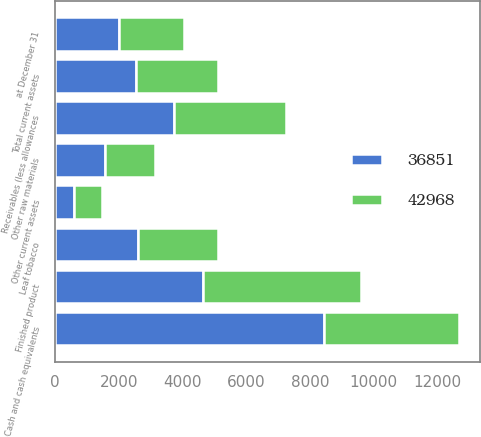Convert chart to OTSL. <chart><loc_0><loc_0><loc_500><loc_500><stacked_bar_chart><ecel><fcel>at December 31<fcel>Cash and cash equivalents<fcel>Receivables (less allowances<fcel>Leaf tobacco<fcel>Other raw materials<fcel>Finished product<fcel>Other current assets<fcel>Total current assets<nl><fcel>36851<fcel>2017<fcel>8447<fcel>3738<fcel>2606<fcel>1563<fcel>4637<fcel>603<fcel>2552<nl><fcel>42968<fcel>2016<fcel>4239<fcel>3499<fcel>2498<fcel>1569<fcel>4950<fcel>853<fcel>2552<nl></chart> 